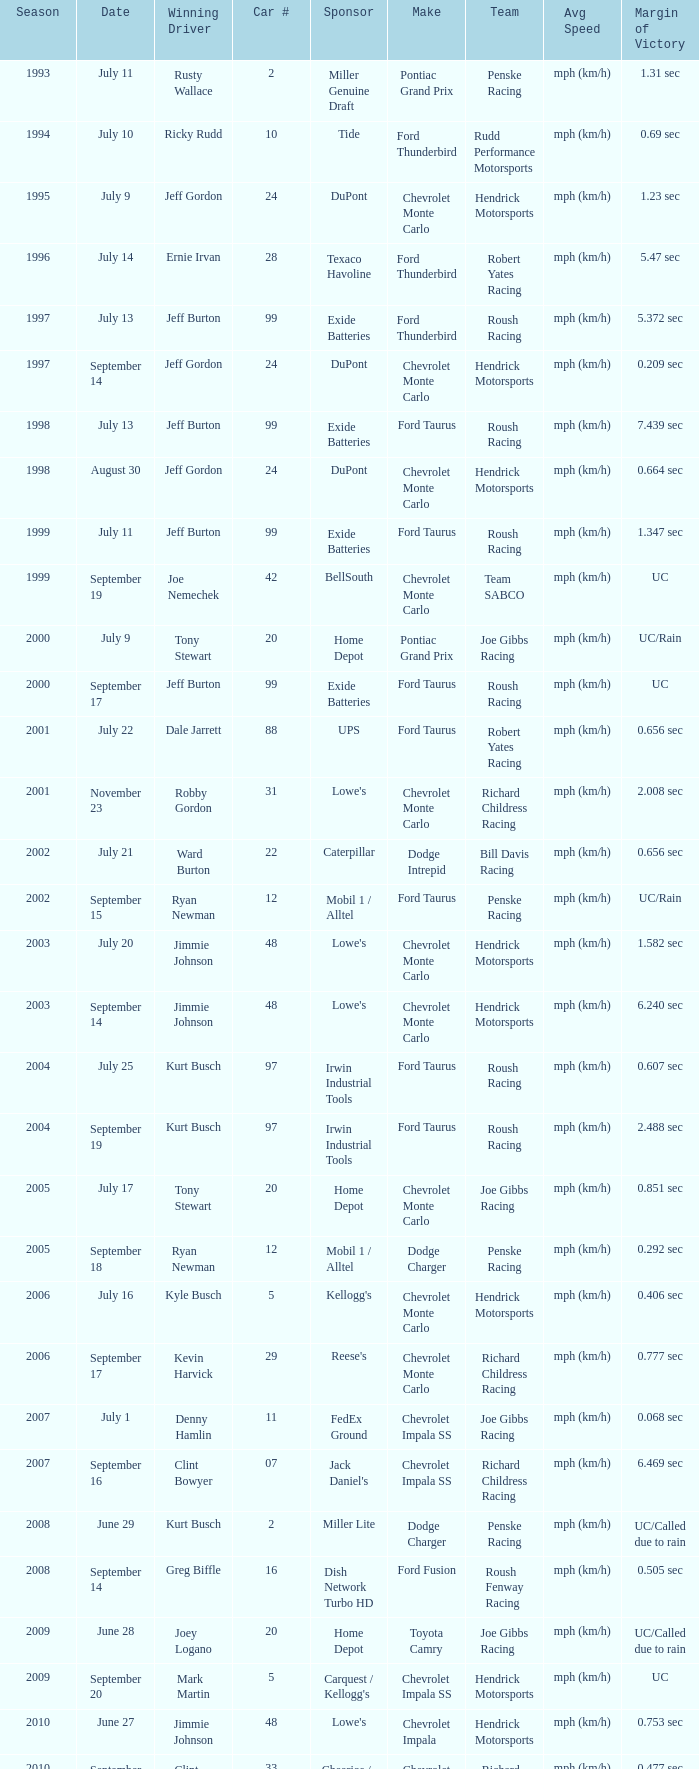Which squad controlled automobile #24 on august 30? Hendrick Motorsports. Parse the table in full. {'header': ['Season', 'Date', 'Winning Driver', 'Car #', 'Sponsor', 'Make', 'Team', 'Avg Speed', 'Margin of Victory'], 'rows': [['1993', 'July 11', 'Rusty Wallace', '2', 'Miller Genuine Draft', 'Pontiac Grand Prix', 'Penske Racing', 'mph (km/h)', '1.31 sec'], ['1994', 'July 10', 'Ricky Rudd', '10', 'Tide', 'Ford Thunderbird', 'Rudd Performance Motorsports', 'mph (km/h)', '0.69 sec'], ['1995', 'July 9', 'Jeff Gordon', '24', 'DuPont', 'Chevrolet Monte Carlo', 'Hendrick Motorsports', 'mph (km/h)', '1.23 sec'], ['1996', 'July 14', 'Ernie Irvan', '28', 'Texaco Havoline', 'Ford Thunderbird', 'Robert Yates Racing', 'mph (km/h)', '5.47 sec'], ['1997', 'July 13', 'Jeff Burton', '99', 'Exide Batteries', 'Ford Thunderbird', 'Roush Racing', 'mph (km/h)', '5.372 sec'], ['1997', 'September 14', 'Jeff Gordon', '24', 'DuPont', 'Chevrolet Monte Carlo', 'Hendrick Motorsports', 'mph (km/h)', '0.209 sec'], ['1998', 'July 13', 'Jeff Burton', '99', 'Exide Batteries', 'Ford Taurus', 'Roush Racing', 'mph (km/h)', '7.439 sec'], ['1998', 'August 30', 'Jeff Gordon', '24', 'DuPont', 'Chevrolet Monte Carlo', 'Hendrick Motorsports', 'mph (km/h)', '0.664 sec'], ['1999', 'July 11', 'Jeff Burton', '99', 'Exide Batteries', 'Ford Taurus', 'Roush Racing', 'mph (km/h)', '1.347 sec'], ['1999', 'September 19', 'Joe Nemechek', '42', 'BellSouth', 'Chevrolet Monte Carlo', 'Team SABCO', 'mph (km/h)', 'UC'], ['2000', 'July 9', 'Tony Stewart', '20', 'Home Depot', 'Pontiac Grand Prix', 'Joe Gibbs Racing', 'mph (km/h)', 'UC/Rain'], ['2000', 'September 17', 'Jeff Burton', '99', 'Exide Batteries', 'Ford Taurus', 'Roush Racing', 'mph (km/h)', 'UC'], ['2001', 'July 22', 'Dale Jarrett', '88', 'UPS', 'Ford Taurus', 'Robert Yates Racing', 'mph (km/h)', '0.656 sec'], ['2001', 'November 23', 'Robby Gordon', '31', "Lowe's", 'Chevrolet Monte Carlo', 'Richard Childress Racing', 'mph (km/h)', '2.008 sec'], ['2002', 'July 21', 'Ward Burton', '22', 'Caterpillar', 'Dodge Intrepid', 'Bill Davis Racing', 'mph (km/h)', '0.656 sec'], ['2002', 'September 15', 'Ryan Newman', '12', 'Mobil 1 / Alltel', 'Ford Taurus', 'Penske Racing', 'mph (km/h)', 'UC/Rain'], ['2003', 'July 20', 'Jimmie Johnson', '48', "Lowe's", 'Chevrolet Monte Carlo', 'Hendrick Motorsports', 'mph (km/h)', '1.582 sec'], ['2003', 'September 14', 'Jimmie Johnson', '48', "Lowe's", 'Chevrolet Monte Carlo', 'Hendrick Motorsports', 'mph (km/h)', '6.240 sec'], ['2004', 'July 25', 'Kurt Busch', '97', 'Irwin Industrial Tools', 'Ford Taurus', 'Roush Racing', 'mph (km/h)', '0.607 sec'], ['2004', 'September 19', 'Kurt Busch', '97', 'Irwin Industrial Tools', 'Ford Taurus', 'Roush Racing', 'mph (km/h)', '2.488 sec'], ['2005', 'July 17', 'Tony Stewart', '20', 'Home Depot', 'Chevrolet Monte Carlo', 'Joe Gibbs Racing', 'mph (km/h)', '0.851 sec'], ['2005', 'September 18', 'Ryan Newman', '12', 'Mobil 1 / Alltel', 'Dodge Charger', 'Penske Racing', 'mph (km/h)', '0.292 sec'], ['2006', 'July 16', 'Kyle Busch', '5', "Kellogg's", 'Chevrolet Monte Carlo', 'Hendrick Motorsports', 'mph (km/h)', '0.406 sec'], ['2006', 'September 17', 'Kevin Harvick', '29', "Reese's", 'Chevrolet Monte Carlo', 'Richard Childress Racing', 'mph (km/h)', '0.777 sec'], ['2007', 'July 1', 'Denny Hamlin', '11', 'FedEx Ground', 'Chevrolet Impala SS', 'Joe Gibbs Racing', 'mph (km/h)', '0.068 sec'], ['2007', 'September 16', 'Clint Bowyer', '07', "Jack Daniel's", 'Chevrolet Impala SS', 'Richard Childress Racing', 'mph (km/h)', '6.469 sec'], ['2008', 'June 29', 'Kurt Busch', '2', 'Miller Lite', 'Dodge Charger', 'Penske Racing', 'mph (km/h)', 'UC/Called due to rain'], ['2008', 'September 14', 'Greg Biffle', '16', 'Dish Network Turbo HD', 'Ford Fusion', 'Roush Fenway Racing', 'mph (km/h)', '0.505 sec'], ['2009', 'June 28', 'Joey Logano', '20', 'Home Depot', 'Toyota Camry', 'Joe Gibbs Racing', 'mph (km/h)', 'UC/Called due to rain'], ['2009', 'September 20', 'Mark Martin', '5', "Carquest / Kellogg's", 'Chevrolet Impala SS', 'Hendrick Motorsports', 'mph (km/h)', 'UC'], ['2010', 'June 27', 'Jimmie Johnson', '48', "Lowe's", 'Chevrolet Impala', 'Hendrick Motorsports', 'mph (km/h)', '0.753 sec'], ['2010', 'September 19', 'Clint Bowyer', '33', 'Cheerios / Hamburger Helper', 'Chevrolet Impala', 'Richard Childress Racing', 'mph (km/h)', '0.477 sec'], ['2011', 'July 17', 'Ryan Newman', '39', 'U.S. Army', 'Chevrolet Impala', 'Stewart-Haas Racing', 'mph (km/h)', '0.773 sec'], ['2011', 'September 25', 'Tony Stewart', '14', 'Mobil 1 / Office Depot', 'Chevrolet Impala', 'Stewart-Haas Racing', 'mph (km/h)', '7.225 sec'], ['2012', 'July 15', 'Kasey Kahne', '5', 'Farmers Insurance', 'Chevrolet Impala', 'Hendrick Motorsports', 'mph (km/h)', '2.738 sec'], ['2012', 'September 23', 'Denny Hamlin', '11', 'FedEx Freight', 'Toyota Camry', 'Joe Gibbs Racing', 'mph (km/h)', '2.675 sec'], ['2013', 'July 14', 'Brian Vickers', '55', "Aaron's", 'Toyota Camry', 'Michael Waltrip Racing', 'mph (km/h)', '.582 sec'], ['2013', 'September 22', 'Matt Kenseth', '20', 'Husky Tools', 'Toyota Camry', 'Joe Gibbs Racing', 'mph (km/h)', '.533 sec']]} 